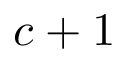<formula> <loc_0><loc_0><loc_500><loc_500>c + 1</formula> 